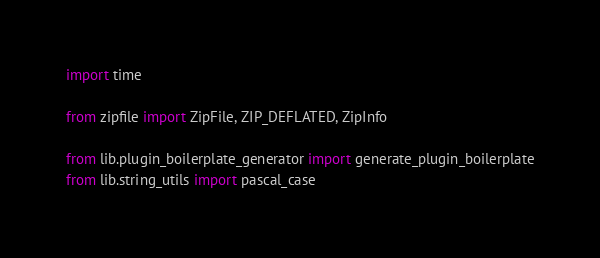<code> <loc_0><loc_0><loc_500><loc_500><_Python_>import time

from zipfile import ZipFile, ZIP_DEFLATED, ZipInfo

from lib.plugin_boilerplate_generator import generate_plugin_boilerplate
from lib.string_utils import pascal_case

</code> 